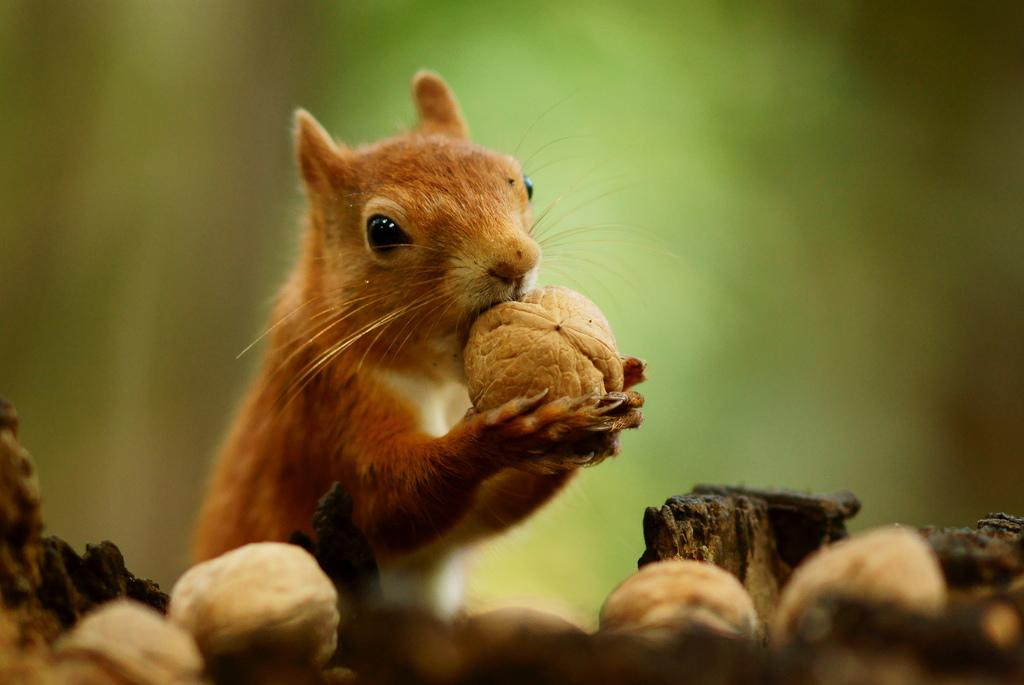What animal is present in the image? There is a squirrel in the image. What is the squirrel holding in the image? The squirrel is holding a walnut in the image. Are there any other walnuts visible in the image? Yes, there are walnuts visible in the image. What is the color of the squirrel in the image? The squirrel is brown in color. What type of plot does the chicken have in the image? There is no chicken present in the image, so it is not possible to determine the type of plot it might have. 